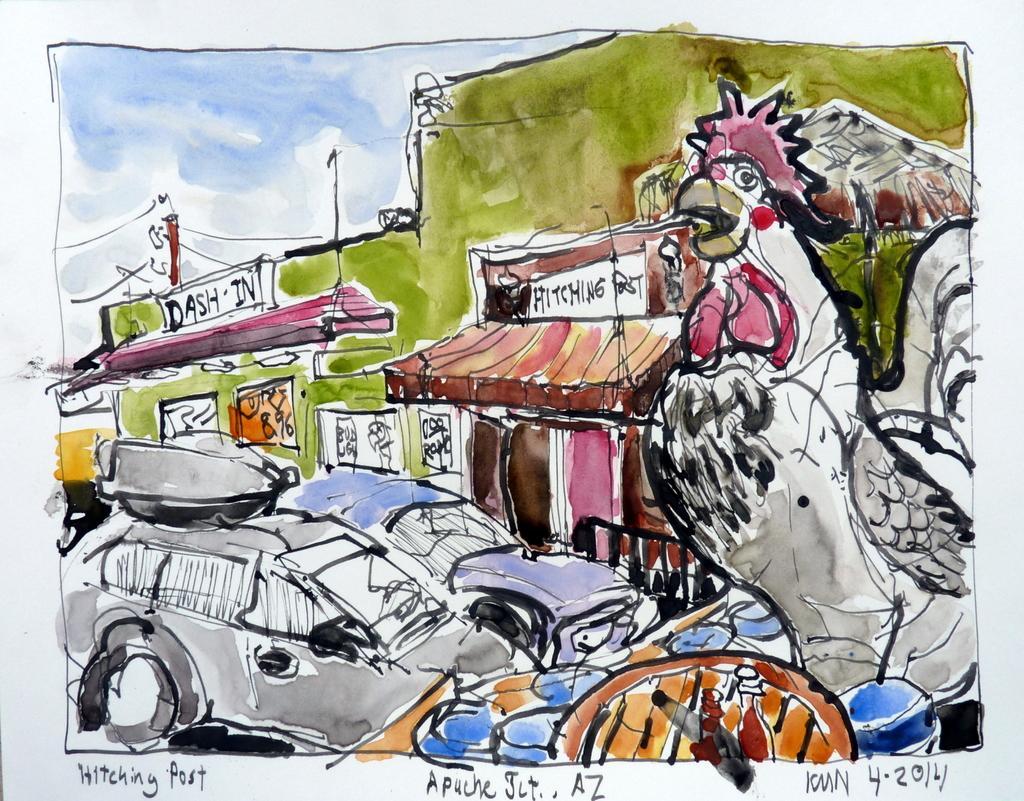How would you summarize this image in a sentence or two? There is a poster having paintings of the vehicles, buildings, a bird, and sky and there are texts on this poster. And the background of this poster is white in color. 